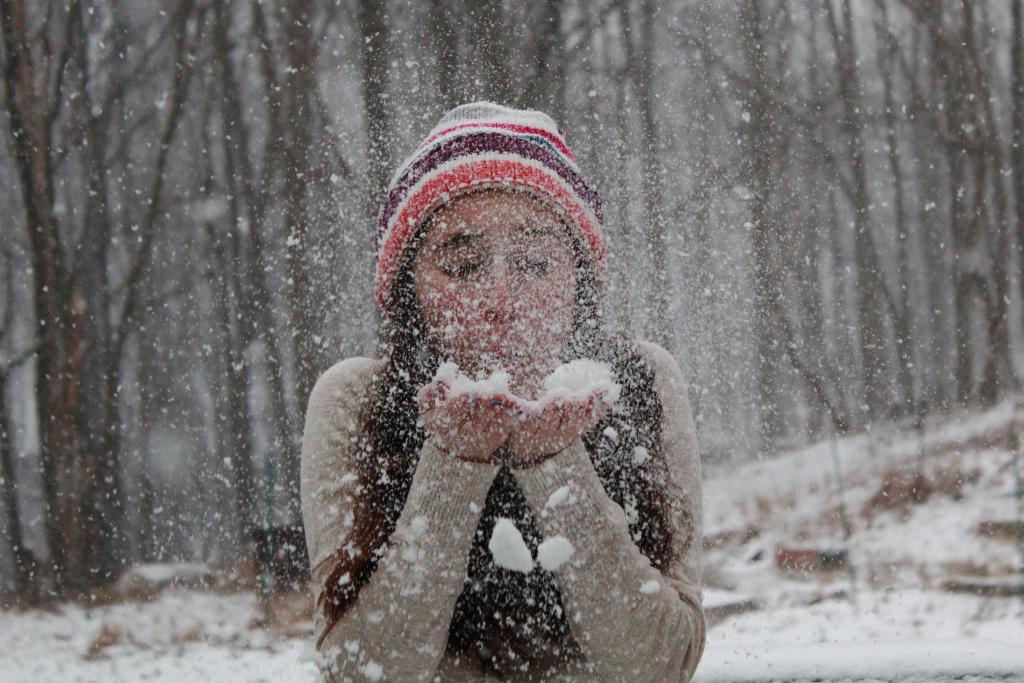Who is present in the image? There is a woman in the image. What is the woman wearing? The woman is wearing a sweater and a cap. What activity is the woman engaged in? The woman is playing with snow. What can be seen in the background of the image? There are trees in the background of the image. What is the condition of the land in the image? The land is covered with snow in the image. How many kittens are playing with the woman in the image? There are no kittens present in the image; the woman is playing with snow. What type of act is the woman performing in the image? The woman is not performing an act in the image; she is simply playing with snow. 